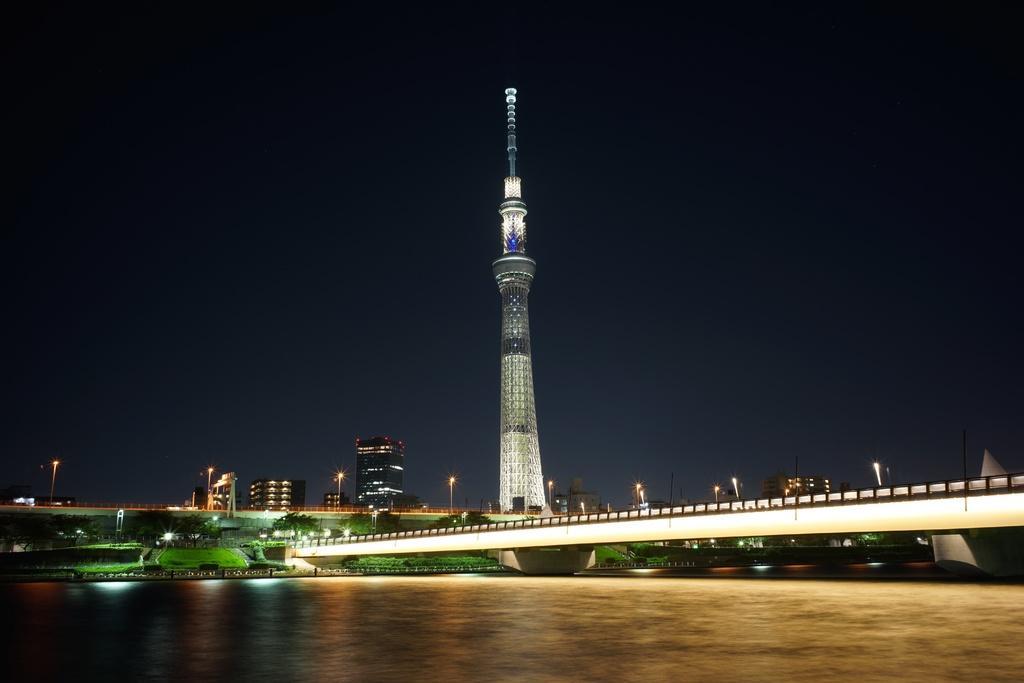Describe this image in one or two sentences. In this image we can see two bridges and a tower, there are some poles, lights, trees, grass and buildings, at the bottom of the image its looks the water. 